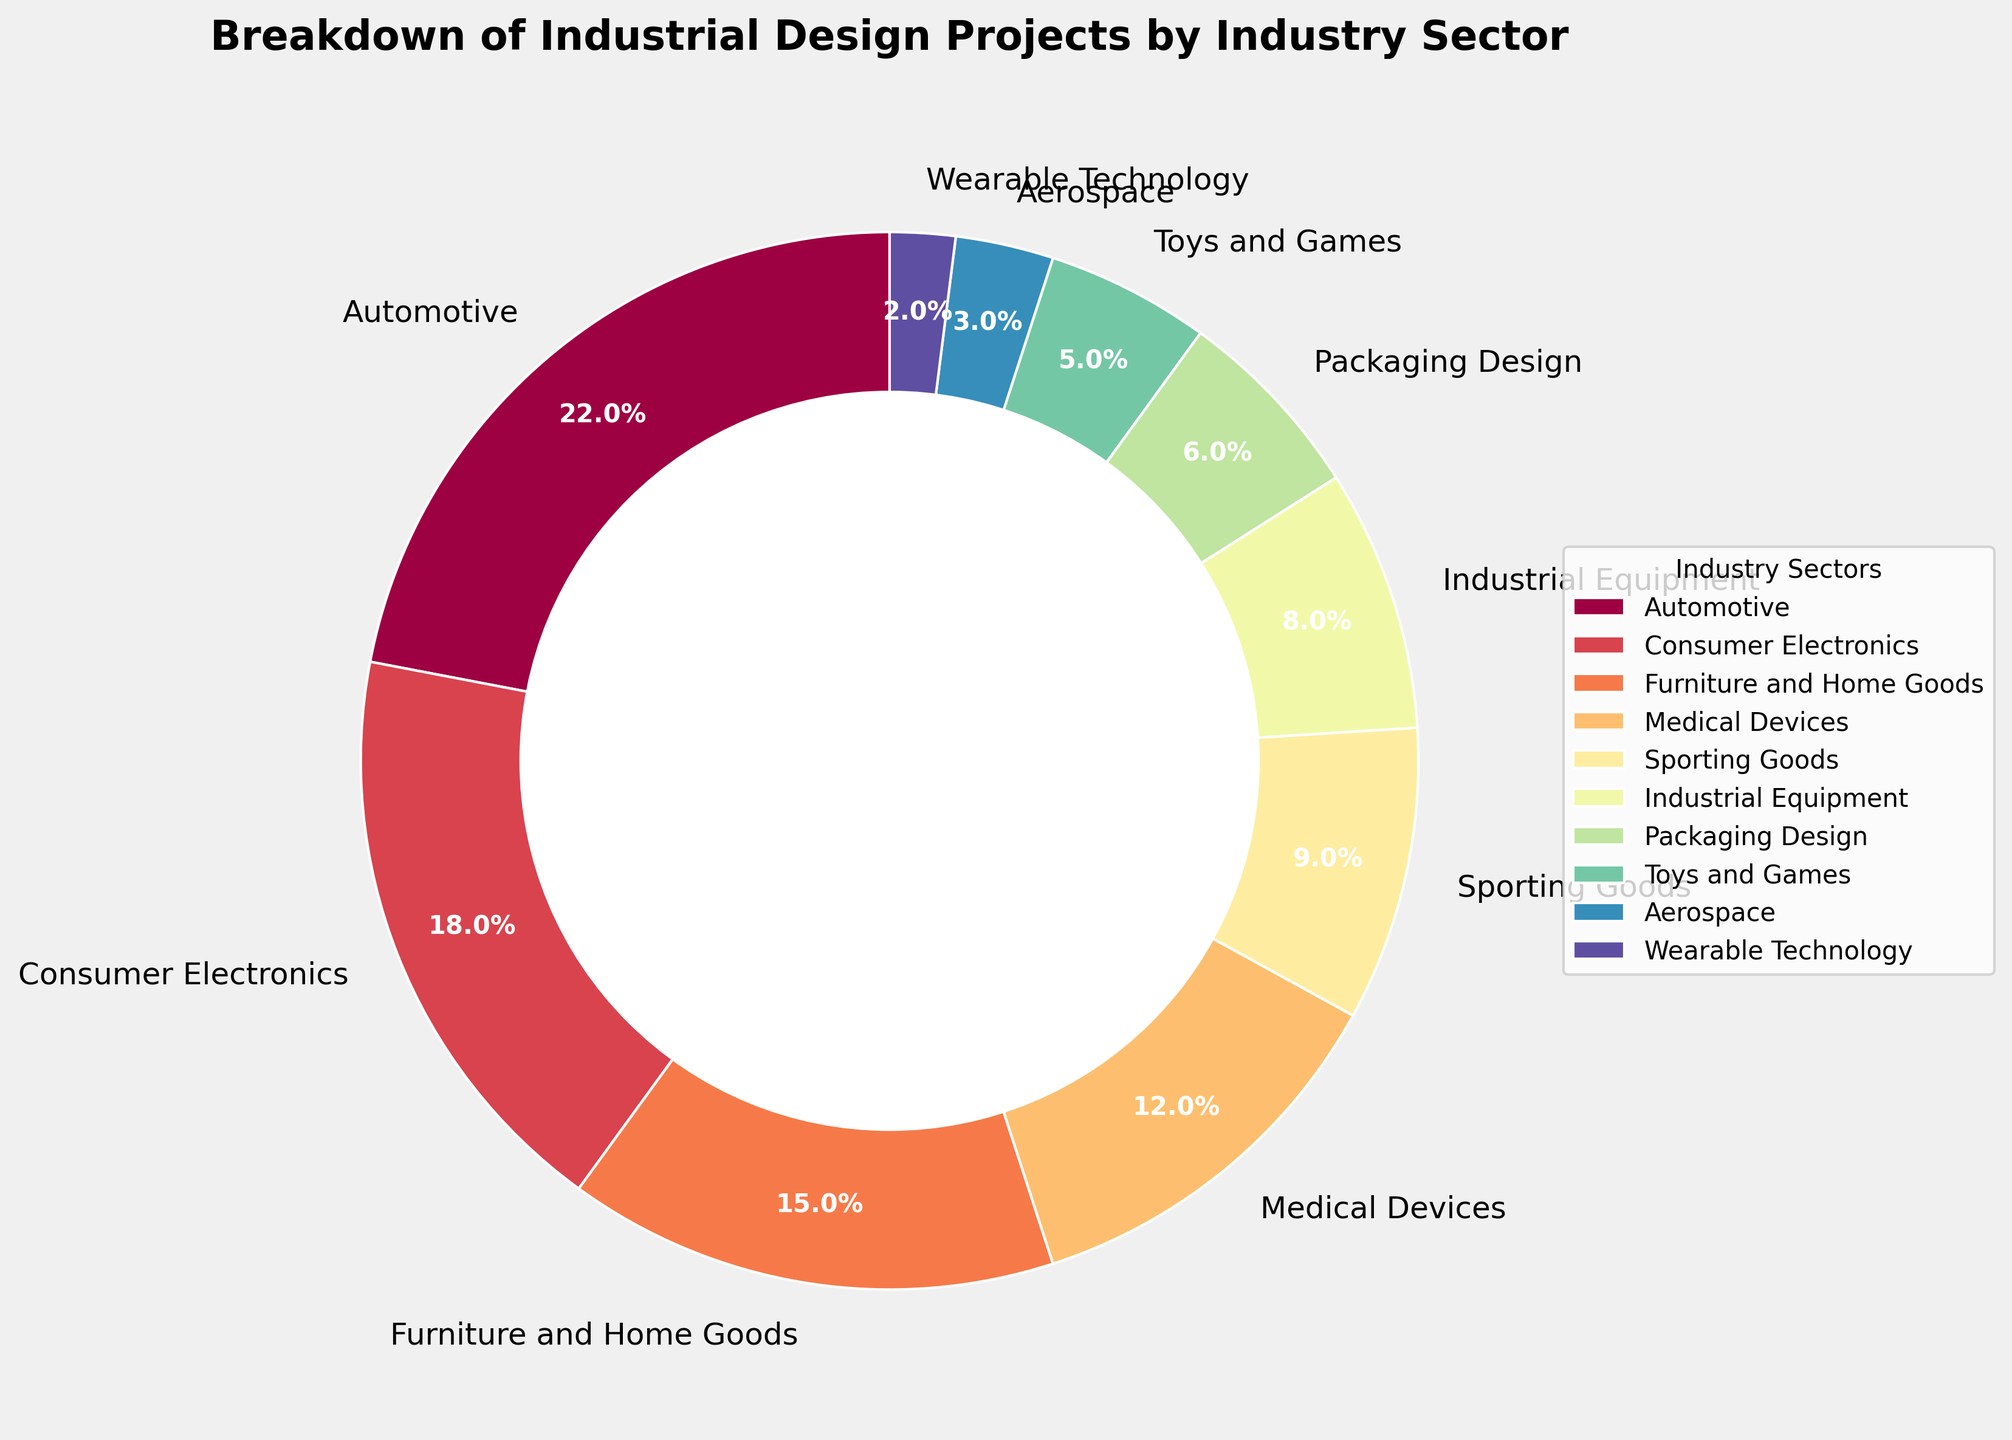What's the largest industry sector represented in this pie chart? The largest segment is visually identifiable by its size. The Automotive sector is the largest, taking up the most space on the chart with 22%.
Answer: Automotive Which two industry sectors combined make up 30% of the projects? By adding the percentages of the sectors, we see that Sporting Goods (9%) and Industrial Equipment (8%) add up to 17%, while Furniture and Home Goods (15%) and Medical Devices (12%) add up to 27%. Packaging Design (6%) and Toys and Games (5%) add up to 11%, which isn’t enough. However, Consumer Electronics (18%) and Medical Devices (12%) add up to exactly 30%.
Answer: Consumer Electronics and Medical Devices What is the total percentage of projects in the combined consumer sectors (Consumer Electronics, Furniture and Home Goods, and Toys and Games)? Summing the percentages of Consumer Electronics (18%), Furniture and Home Goods (15%), and Toys and Games (5%) gives us 18 + 15 + 5 = 38%.
Answer: 38% How does the percentage of Automotive projects compare to the combined percentage of Aerospace and Wearable Technology projects? Automotive is 22%. Aerospace and Wearable Technology add up to 3% + 2% = 5%. 22% (Automotive) is much larger than 5% (Aerospace and Wearable Technology combined).
Answer: Automotive is larger Which sector has a larger representation: Industrial Equipment or Packaging Design? By looking at the percentages, Industrial Equipment has 8% while Packaging Design has 6%. Hence, Industrial Equipment has a larger representation.
Answer: Industrial Equipment What is the difference in project percentage between the highest and the lowest represented sectors? The highest represented sector is Automotive (22%) and the lowest is Wearable Technology (2%). The difference is 22% - 2% = 20%.
Answer: 20% How much more does the Automotive sector represent compared to the Sporting Goods sector? The Automotive sector represents 22% while the Sporting Goods sector represents 9%. The difference is 22% - 9% = 13%.
Answer: 13% If you were to group Medical Devices and Wearable Technology together, what would be their combined percentage? By adding the percentages of Medical Devices (12%) and Wearable Technology (2%), we get 12% + 2% = 14%.
Answer: 14% Identify the sectors that occupy less than 10% of the chart each. From the chart, the sectors with less than 10% are: Sporting Goods (9%), Industrial Equipment (8%), Packaging Design (6%), Toys and Games (5%), Aerospace (3%), and Wearable Technology (2%).
Answer: Sporting Goods, Industrial Equipment, Packaging Design, Toys and Games, Aerospace, and Wearable Technology 